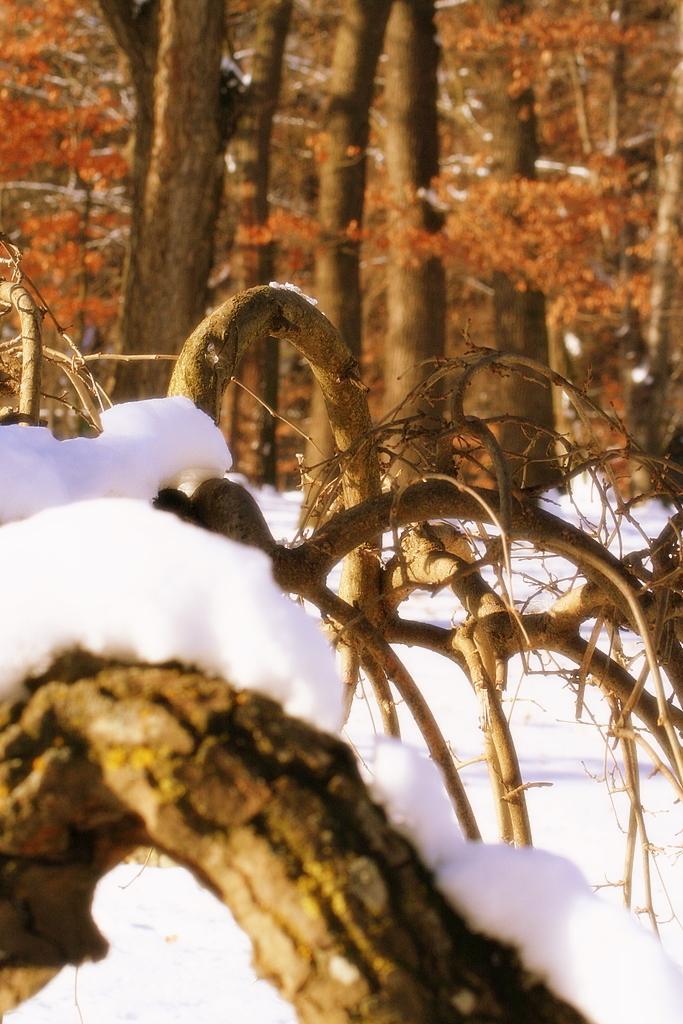In one or two sentences, can you explain what this image depicts? At the bottom of the picture, we see a tree which is covered with ice and in the background, there are many trees. 